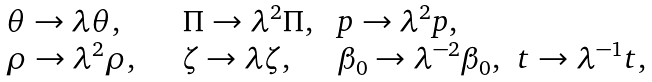Convert formula to latex. <formula><loc_0><loc_0><loc_500><loc_500>\begin{array} { l l l l } \theta \to \lambda \theta , & \Pi \to \lambda ^ { 2 } \Pi , & p \to \lambda ^ { 2 } p , & \ \\ \rho \to \lambda ^ { 2 } \rho , \quad & \zeta \to \lambda \zeta , \quad & \beta _ { 0 } \to \lambda ^ { - 2 } \beta _ { 0 } , & t \to { \lambda } ^ { - 1 } t , \end{array}</formula> 